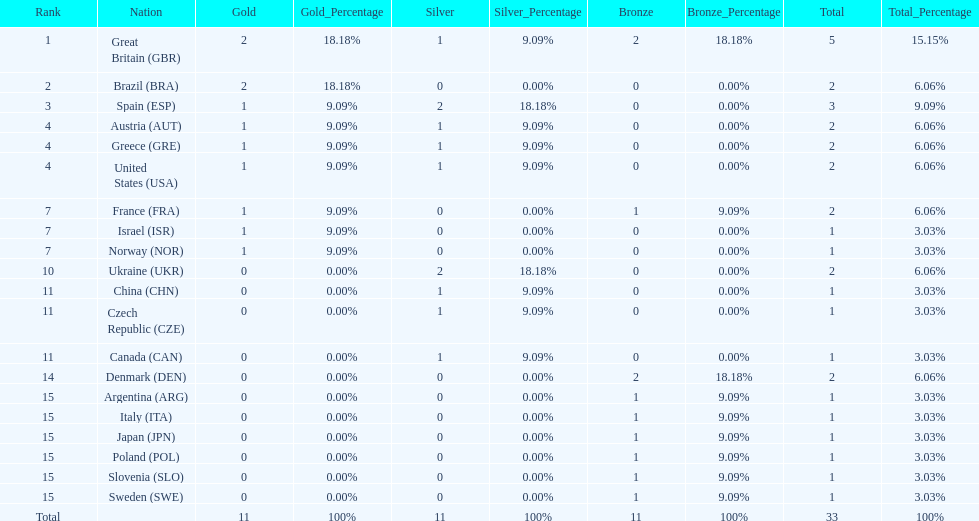What was the total number of medals won by united states? 2. 